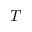Convert formula to latex. <formula><loc_0><loc_0><loc_500><loc_500>T</formula> 